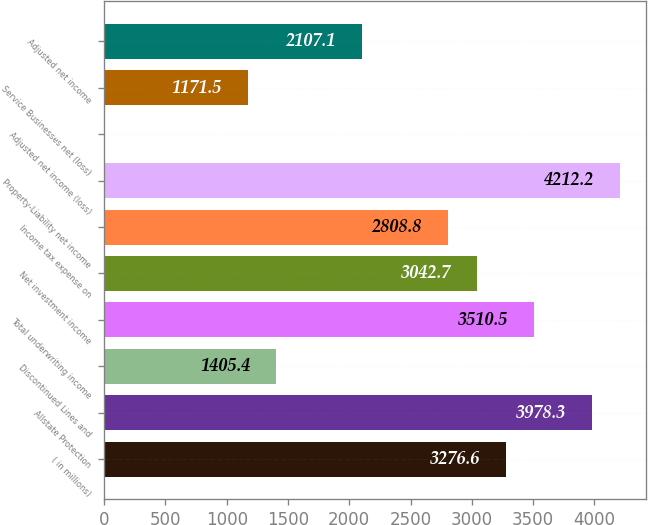Convert chart. <chart><loc_0><loc_0><loc_500><loc_500><bar_chart><fcel>( in millions)<fcel>Allstate Protection<fcel>Discontinued Lines and<fcel>Total underwriting income<fcel>Net investment income<fcel>Income tax expense on<fcel>Property-Liability net income<fcel>Adjusted net income (loss)<fcel>Service Businesses net (loss)<fcel>Adjusted net income<nl><fcel>3276.6<fcel>3978.3<fcel>1405.4<fcel>3510.5<fcel>3042.7<fcel>2808.8<fcel>4212.2<fcel>2<fcel>1171.5<fcel>2107.1<nl></chart> 